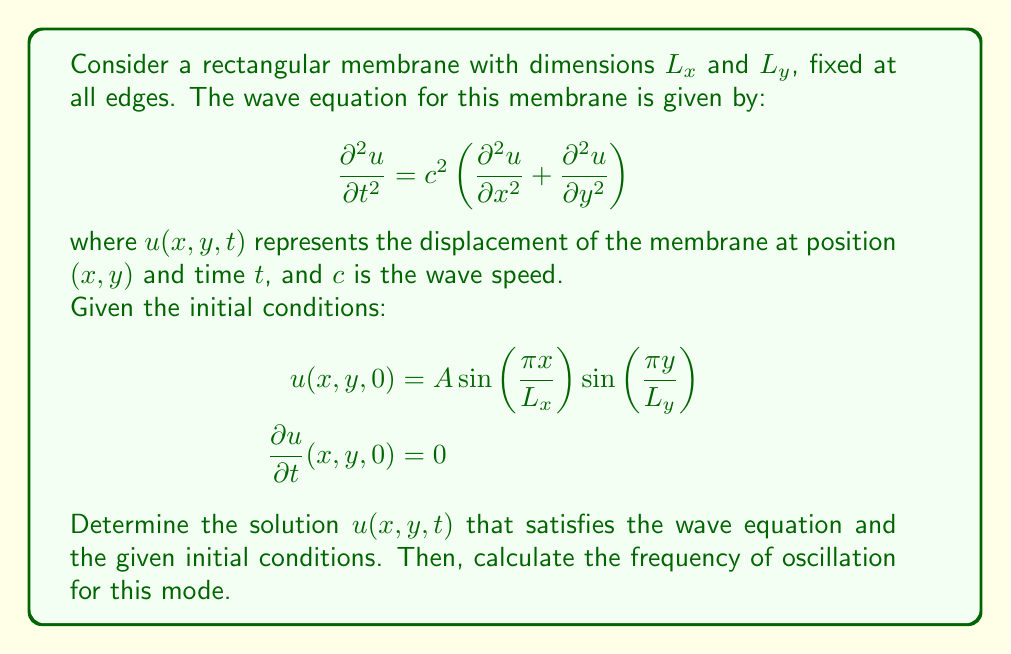Solve this math problem. To solve this problem, we'll follow these steps:

1) First, we need to recognize that the given initial condition satisfies the boundary conditions (fixed edges) of the membrane.

2) We can assume a solution of the form:
   $$u(x,y,t) = X(x)Y(y)T(t)$$

3) Substituting this into the wave equation and separating variables, we get:
   $$\frac{T''(t)}{c^2T(t)} = -\left(\frac{X''(x)}{X(x)} + \frac{Y''(y)}{Y(y)}\right) = -k^2$$
   where $k^2$ is a separation constant.

4) This leads to three ordinary differential equations:
   $$X''(x) + k_x^2X(x) = 0$$
   $$Y''(y) + k_y^2Y(y) = 0$$
   $$T''(t) + c^2k^2T(t) = 0$$
   where $k^2 = k_x^2 + k_y^2$

5) The solutions to these equations, considering the boundary conditions, are:
   $$X(x) = \sin\left(\frac{n\pi x}{L_x}\right)$$
   $$Y(y) = \sin\left(\frac{m\pi y}{L_y}\right)$$
   $$T(t) = A\cos(\omega t) + B\sin(\omega t)$$
   where $n$ and $m$ are positive integers, and $\omega = ck = c\sqrt{(\frac{n\pi}{L_x})^2 + (\frac{m\pi}{L_y})^2}$

6) Comparing with the given initial conditions, we see that $n=m=1$, $B=0$, and the solution is:
   $$u(x,y,t) = A \sin\left(\frac{\pi x}{L_x}\right)\sin\left(\frac{\pi y}{L_y}\right)\cos(\omega t)$$

7) The frequency of oscillation is given by:
   $$f = \frac{\omega}{2\pi} = \frac{c}{2\pi}\sqrt{(\frac{\pi}{L_x})^2 + (\frac{\pi}{L_y})^2}$$
Answer: The solution to the wave equation with the given initial conditions is:
$$u(x,y,t) = A \sin\left(\frac{\pi x}{L_x}\right)\sin\left(\frac{\pi y}{L_y}\right)\cos(\omega t)$$
where $\omega = c\sqrt{(\frac{\pi}{L_x})^2 + (\frac{\pi}{L_y})^2}$

The frequency of oscillation for this mode is:
$$f = \frac{c}{2\pi}\sqrt{(\frac{\pi}{L_x})^2 + (\frac{\pi}{L_y})^2}$$ 